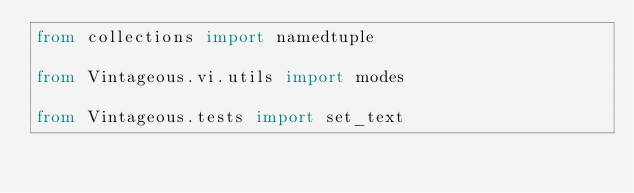<code> <loc_0><loc_0><loc_500><loc_500><_Python_>from collections import namedtuple

from Vintageous.vi.utils import modes

from Vintageous.tests import set_text</code> 